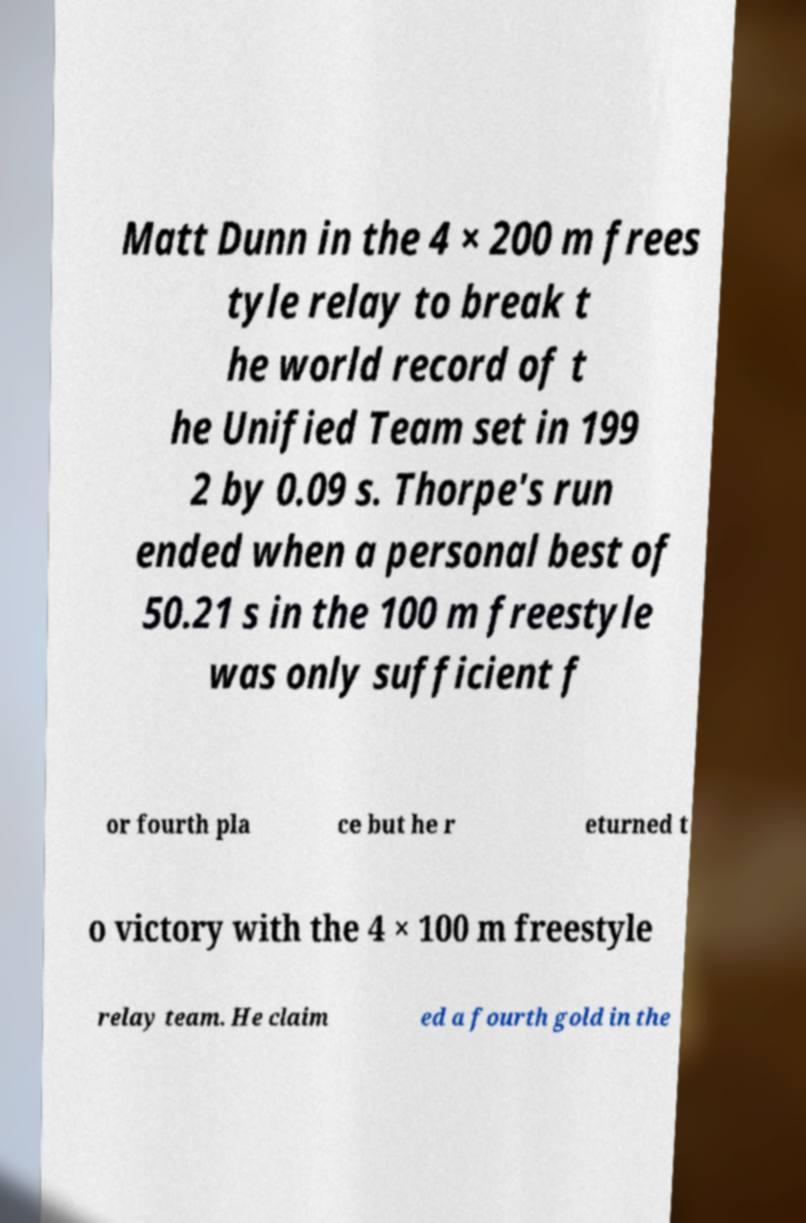For documentation purposes, I need the text within this image transcribed. Could you provide that? Matt Dunn in the 4 × 200 m frees tyle relay to break t he world record of t he Unified Team set in 199 2 by 0.09 s. Thorpe's run ended when a personal best of 50.21 s in the 100 m freestyle was only sufficient f or fourth pla ce but he r eturned t o victory with the 4 × 100 m freestyle relay team. He claim ed a fourth gold in the 